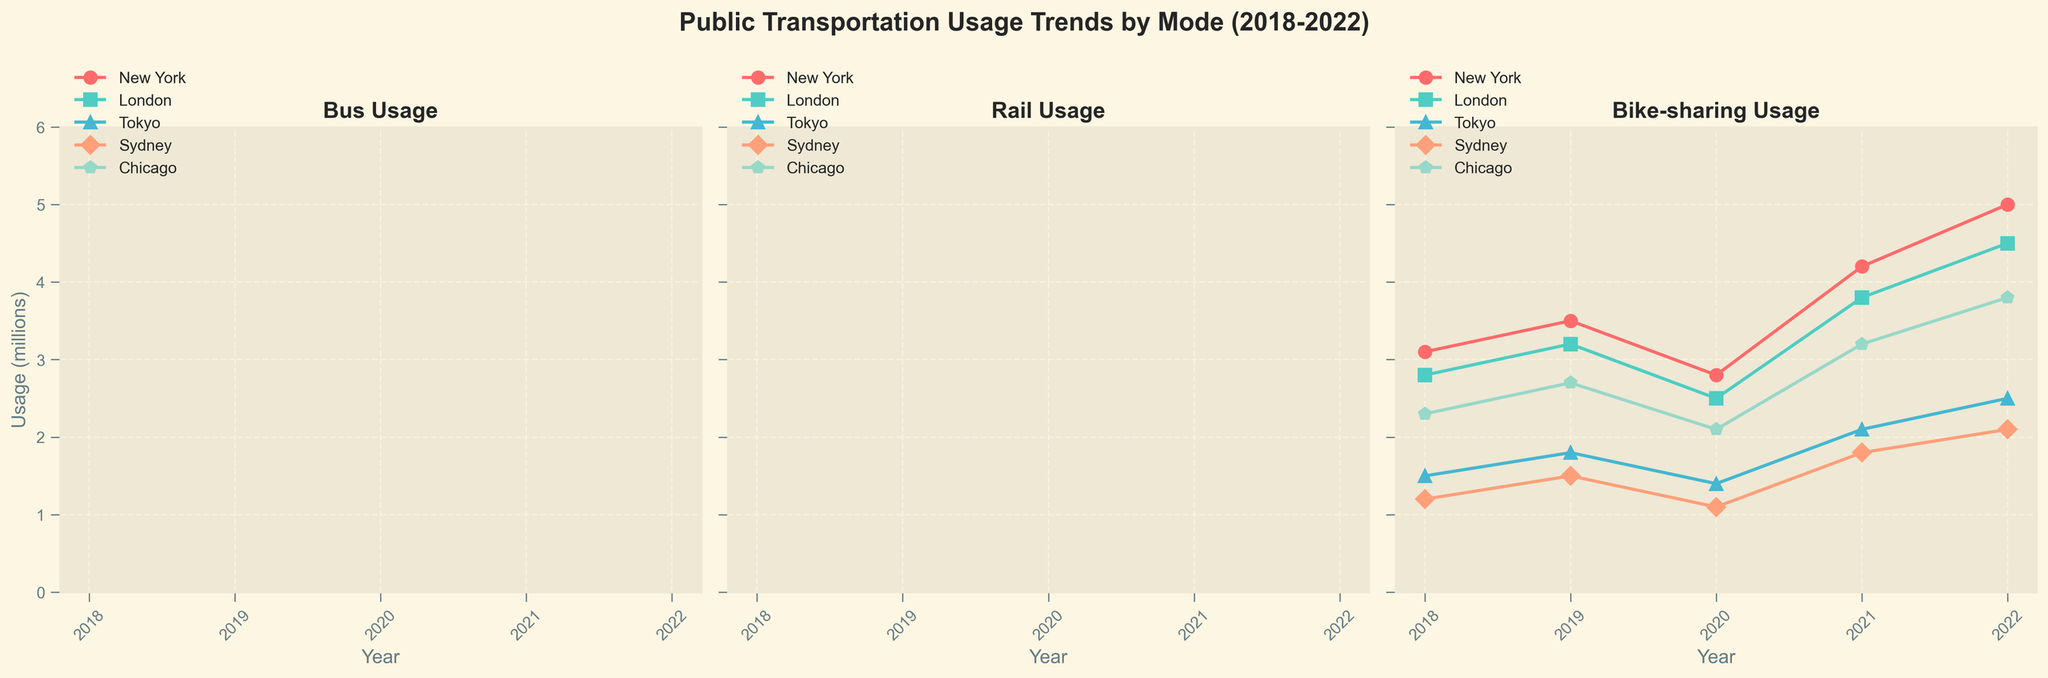What is the title of the subplot showing bike-sharing usage? The subplot for bike-sharing usage has its own title at the top, which is meant to identify the specific mode of transportation it represents.
Answer: Bike-sharing Usage How many years are displayed across all subplots? Each subplot represents data over multiple years, which can be counted from the x-axis labels that show "Year". Identifying these labels can give us a total count.
Answer: 5 Which city had the highest bus usage in 2018? By looking at the first subplot (Bus Usage) and tracing to the 2018 data points, the city with the highest value can be identified.
Answer: New York What is the difference in rail usage between Tokyo and Chicago in 2022? To find the difference, locate the 2022 data points on the Rail Usage subplot for both Tokyo and Chicago, then subtract Chicago's value from Tokyo's value.
Answer: 25.9 Which city showed a steady increase in bike-sharing usage from 2018 to 2022? On the bike-sharing usage subplot, analyze each city's trend from 2018 to 2022. The city with consistently increasing values across all years is the answer.
Answer: Chicago How did Sydney's bus usage change from 2020 to 2021? Look at the Bus Usage subplot and find Sydney's data points for 2020 and 2021. Subtract the 2020 value from the 2021 value to determine the change.
Answer: Increased by 6.5 Which mode of transportation saw the most significant drop in usage during 2020? Examine all three subplots focusing on the difference between 2019 and 2020. The mode with the largest drop in value is the answer.
Answer: Rail Between New York and London, which city had a higher bike-sharing usage in 2021? Compare the data points for New York and London on the Bike-sharing Usage subplot for the year 2021. The city with the higher value is the answer.
Answer: New York What was the trend of rail usage in Tokyo from 2018 to 2022? On the Rail Usage subplot, observe Tokyo's data points from 2018 to 2022 to describe whether the trend is increasing, decreasing, or fluctuating.
Answer: Mostly decreasing with a slight recovery in 2022 In which year did Chicago see the highest bus usage? On the Bus Usage subplot, trace Chicago's values across all years and identify the year with the maximum value.
Answer: 2018 